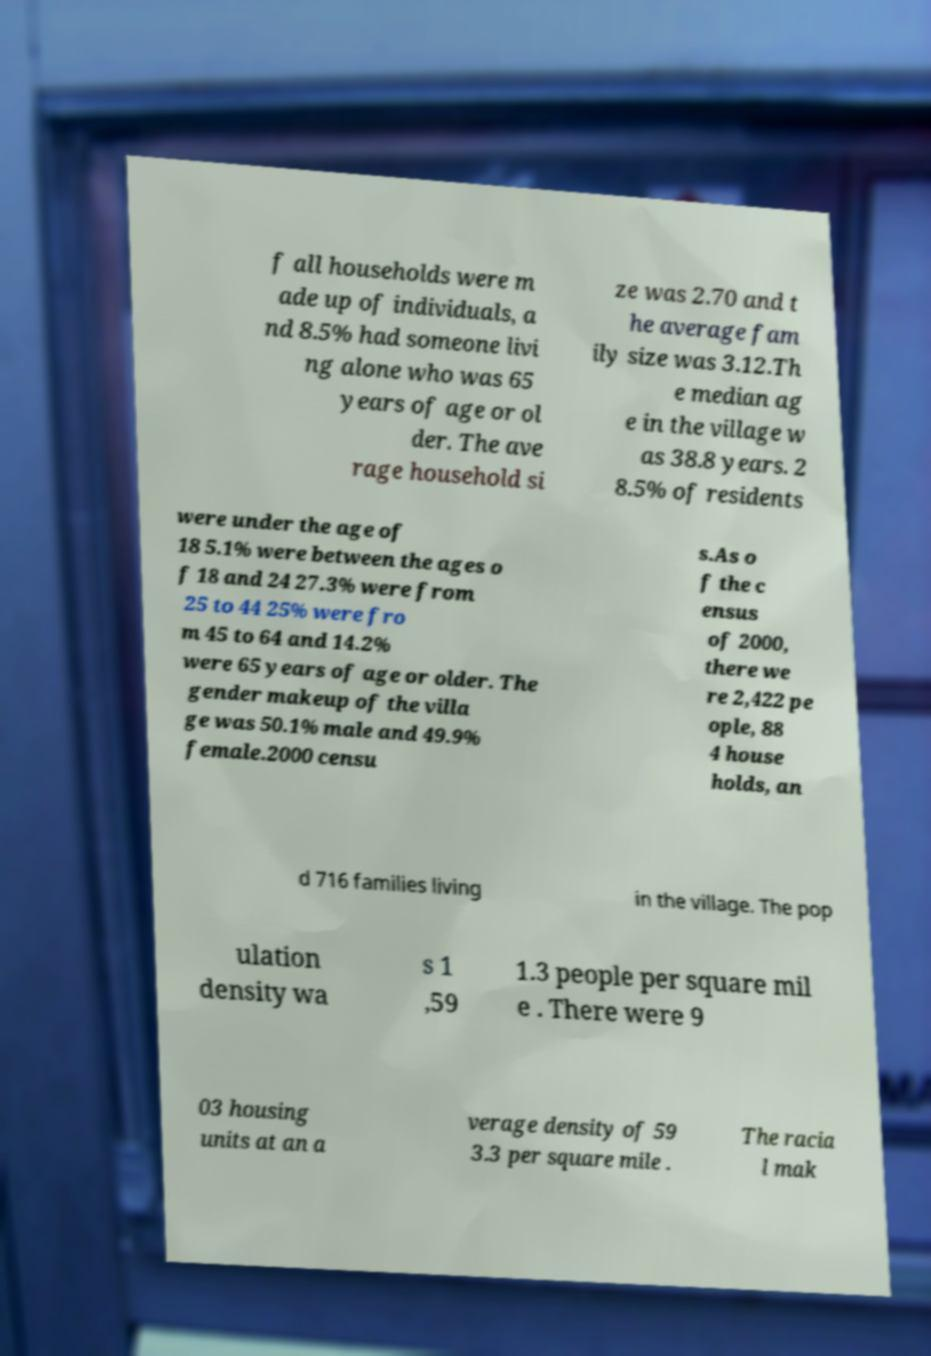Could you assist in decoding the text presented in this image and type it out clearly? f all households were m ade up of individuals, a nd 8.5% had someone livi ng alone who was 65 years of age or ol der. The ave rage household si ze was 2.70 and t he average fam ily size was 3.12.Th e median ag e in the village w as 38.8 years. 2 8.5% of residents were under the age of 18 5.1% were between the ages o f 18 and 24 27.3% were from 25 to 44 25% were fro m 45 to 64 and 14.2% were 65 years of age or older. The gender makeup of the villa ge was 50.1% male and 49.9% female.2000 censu s.As o f the c ensus of 2000, there we re 2,422 pe ople, 88 4 house holds, an d 716 families living in the village. The pop ulation density wa s 1 ,59 1.3 people per square mil e . There were 9 03 housing units at an a verage density of 59 3.3 per square mile . The racia l mak 